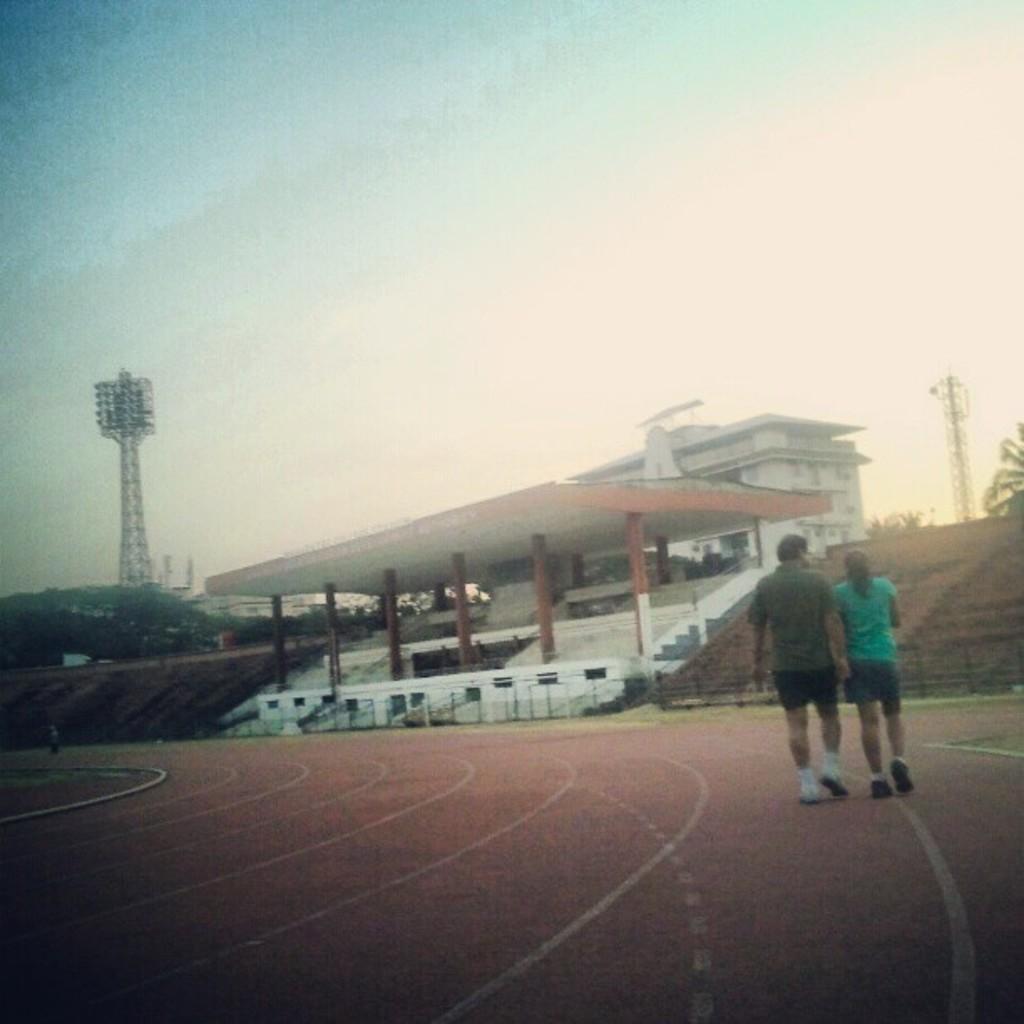Could you give a brief overview of what you see in this image? In this picture we can see a man and a woman walking in the ground. We can see a building, towers and trees in the background. 